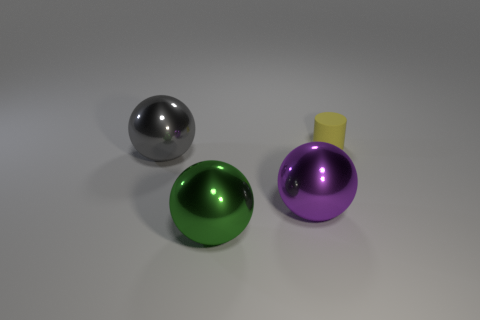Can you infer anything about the setting these objects are placed in? The objects are situated on a flat, horizontal surface with a subtle gradient, and the neutral background with soft shadows suggests an indoor environment with controlled lighting, like a studio setup. 
Is there an indication about the scale or size of the objects relative to each other? The purple object with the yellow top appears to be smaller than both the silver and the green spheres, although without additional context or reference points, an exact determination of scale is challenging. 